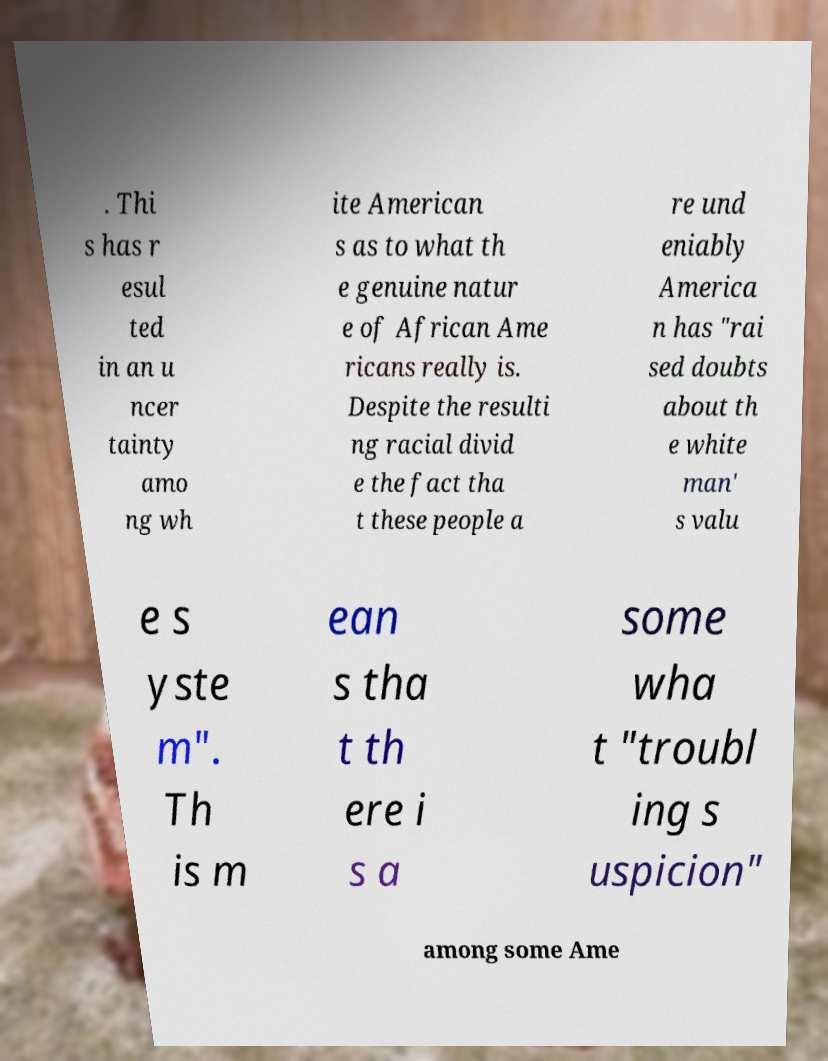Could you extract and type out the text from this image? . Thi s has r esul ted in an u ncer tainty amo ng wh ite American s as to what th e genuine natur e of African Ame ricans really is. Despite the resulti ng racial divid e the fact tha t these people a re und eniably America n has "rai sed doubts about th e white man' s valu e s yste m". Th is m ean s tha t th ere i s a some wha t "troubl ing s uspicion" among some Ame 